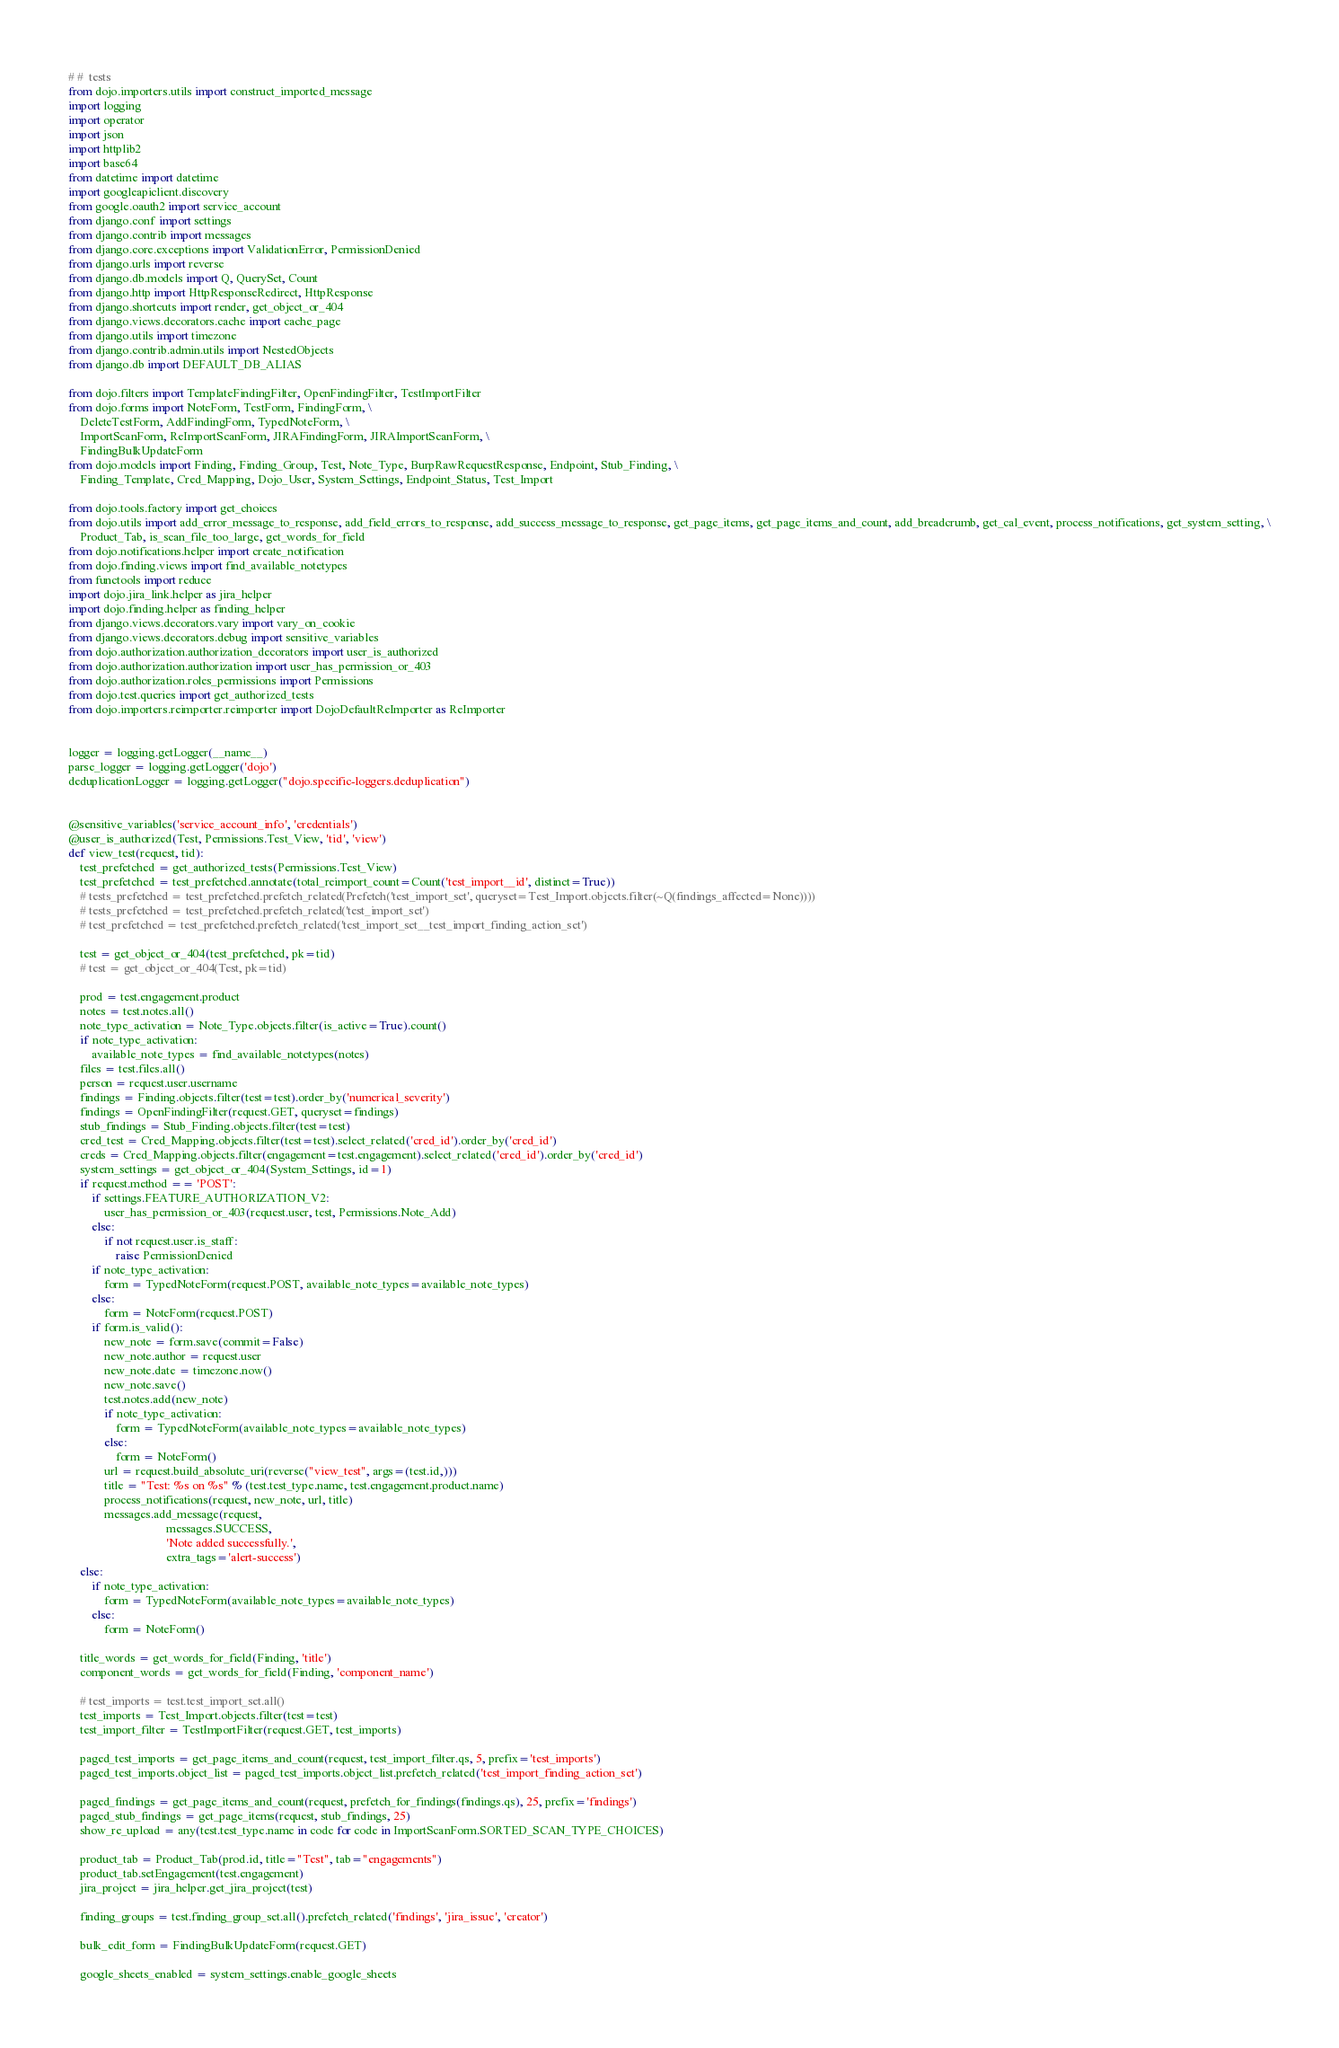<code> <loc_0><loc_0><loc_500><loc_500><_Python_># #  tests
from dojo.importers.utils import construct_imported_message
import logging
import operator
import json
import httplib2
import base64
from datetime import datetime
import googleapiclient.discovery
from google.oauth2 import service_account
from django.conf import settings
from django.contrib import messages
from django.core.exceptions import ValidationError, PermissionDenied
from django.urls import reverse
from django.db.models import Q, QuerySet, Count
from django.http import HttpResponseRedirect, HttpResponse
from django.shortcuts import render, get_object_or_404
from django.views.decorators.cache import cache_page
from django.utils import timezone
from django.contrib.admin.utils import NestedObjects
from django.db import DEFAULT_DB_ALIAS

from dojo.filters import TemplateFindingFilter, OpenFindingFilter, TestImportFilter
from dojo.forms import NoteForm, TestForm, FindingForm, \
    DeleteTestForm, AddFindingForm, TypedNoteForm, \
    ImportScanForm, ReImportScanForm, JIRAFindingForm, JIRAImportScanForm, \
    FindingBulkUpdateForm
from dojo.models import Finding, Finding_Group, Test, Note_Type, BurpRawRequestResponse, Endpoint, Stub_Finding, \
    Finding_Template, Cred_Mapping, Dojo_User, System_Settings, Endpoint_Status, Test_Import

from dojo.tools.factory import get_choices
from dojo.utils import add_error_message_to_response, add_field_errors_to_response, add_success_message_to_response, get_page_items, get_page_items_and_count, add_breadcrumb, get_cal_event, process_notifications, get_system_setting, \
    Product_Tab, is_scan_file_too_large, get_words_for_field
from dojo.notifications.helper import create_notification
from dojo.finding.views import find_available_notetypes
from functools import reduce
import dojo.jira_link.helper as jira_helper
import dojo.finding.helper as finding_helper
from django.views.decorators.vary import vary_on_cookie
from django.views.decorators.debug import sensitive_variables
from dojo.authorization.authorization_decorators import user_is_authorized
from dojo.authorization.authorization import user_has_permission_or_403
from dojo.authorization.roles_permissions import Permissions
from dojo.test.queries import get_authorized_tests
from dojo.importers.reimporter.reimporter import DojoDefaultReImporter as ReImporter


logger = logging.getLogger(__name__)
parse_logger = logging.getLogger('dojo')
deduplicationLogger = logging.getLogger("dojo.specific-loggers.deduplication")


@sensitive_variables('service_account_info', 'credentials')
@user_is_authorized(Test, Permissions.Test_View, 'tid', 'view')
def view_test(request, tid):
    test_prefetched = get_authorized_tests(Permissions.Test_View)
    test_prefetched = test_prefetched.annotate(total_reimport_count=Count('test_import__id', distinct=True))
    # tests_prefetched = test_prefetched.prefetch_related(Prefetch('test_import_set', queryset=Test_Import.objects.filter(~Q(findings_affected=None))))
    # tests_prefetched = test_prefetched.prefetch_related('test_import_set')
    # test_prefetched = test_prefetched.prefetch_related('test_import_set__test_import_finding_action_set')

    test = get_object_or_404(test_prefetched, pk=tid)
    # test = get_object_or_404(Test, pk=tid)

    prod = test.engagement.product
    notes = test.notes.all()
    note_type_activation = Note_Type.objects.filter(is_active=True).count()
    if note_type_activation:
        available_note_types = find_available_notetypes(notes)
    files = test.files.all()
    person = request.user.username
    findings = Finding.objects.filter(test=test).order_by('numerical_severity')
    findings = OpenFindingFilter(request.GET, queryset=findings)
    stub_findings = Stub_Finding.objects.filter(test=test)
    cred_test = Cred_Mapping.objects.filter(test=test).select_related('cred_id').order_by('cred_id')
    creds = Cred_Mapping.objects.filter(engagement=test.engagement).select_related('cred_id').order_by('cred_id')
    system_settings = get_object_or_404(System_Settings, id=1)
    if request.method == 'POST':
        if settings.FEATURE_AUTHORIZATION_V2:
            user_has_permission_or_403(request.user, test, Permissions.Note_Add)
        else:
            if not request.user.is_staff:
                raise PermissionDenied
        if note_type_activation:
            form = TypedNoteForm(request.POST, available_note_types=available_note_types)
        else:
            form = NoteForm(request.POST)
        if form.is_valid():
            new_note = form.save(commit=False)
            new_note.author = request.user
            new_note.date = timezone.now()
            new_note.save()
            test.notes.add(new_note)
            if note_type_activation:
                form = TypedNoteForm(available_note_types=available_note_types)
            else:
                form = NoteForm()
            url = request.build_absolute_uri(reverse("view_test", args=(test.id,)))
            title = "Test: %s on %s" % (test.test_type.name, test.engagement.product.name)
            process_notifications(request, new_note, url, title)
            messages.add_message(request,
                                 messages.SUCCESS,
                                 'Note added successfully.',
                                 extra_tags='alert-success')
    else:
        if note_type_activation:
            form = TypedNoteForm(available_note_types=available_note_types)
        else:
            form = NoteForm()

    title_words = get_words_for_field(Finding, 'title')
    component_words = get_words_for_field(Finding, 'component_name')

    # test_imports = test.test_import_set.all()
    test_imports = Test_Import.objects.filter(test=test)
    test_import_filter = TestImportFilter(request.GET, test_imports)

    paged_test_imports = get_page_items_and_count(request, test_import_filter.qs, 5, prefix='test_imports')
    paged_test_imports.object_list = paged_test_imports.object_list.prefetch_related('test_import_finding_action_set')

    paged_findings = get_page_items_and_count(request, prefetch_for_findings(findings.qs), 25, prefix='findings')
    paged_stub_findings = get_page_items(request, stub_findings, 25)
    show_re_upload = any(test.test_type.name in code for code in ImportScanForm.SORTED_SCAN_TYPE_CHOICES)

    product_tab = Product_Tab(prod.id, title="Test", tab="engagements")
    product_tab.setEngagement(test.engagement)
    jira_project = jira_helper.get_jira_project(test)

    finding_groups = test.finding_group_set.all().prefetch_related('findings', 'jira_issue', 'creator')

    bulk_edit_form = FindingBulkUpdateForm(request.GET)

    google_sheets_enabled = system_settings.enable_google_sheets</code> 